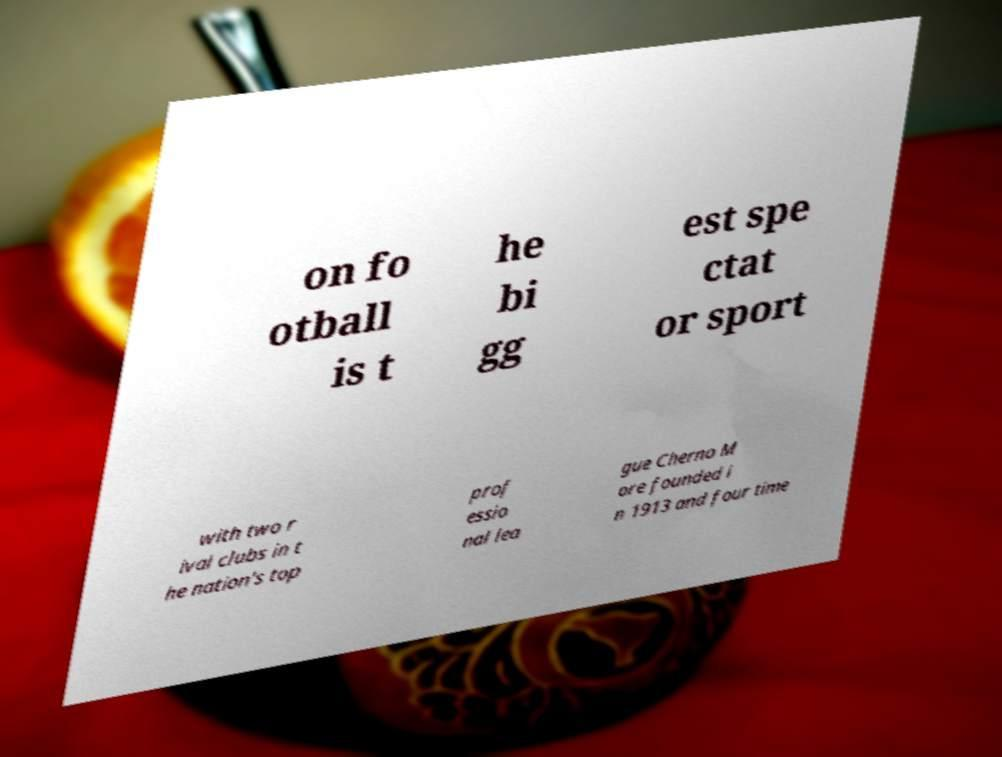Please read and relay the text visible in this image. What does it say? on fo otball is t he bi gg est spe ctat or sport with two r ival clubs in t he nation's top prof essio nal lea gue Cherno M ore founded i n 1913 and four time 